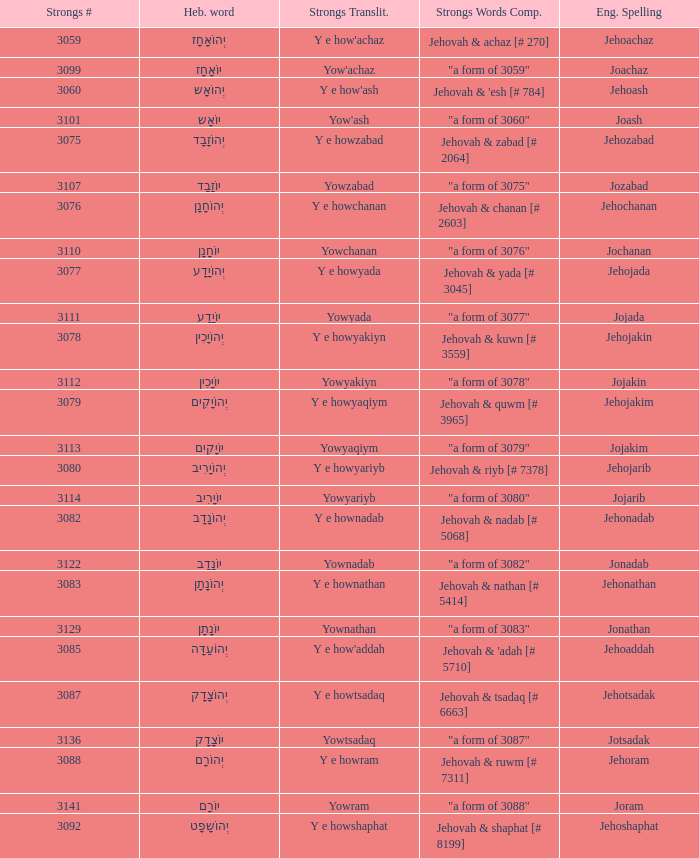What is the strongs words compounded when the english spelling is jonadab? "a form of 3082". 